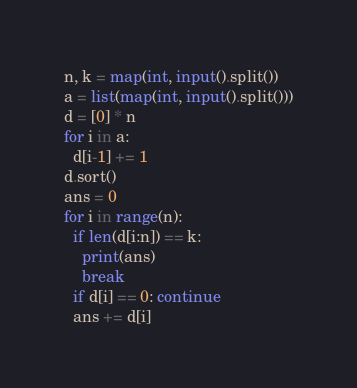<code> <loc_0><loc_0><loc_500><loc_500><_Python_>n, k = map(int, input().split())
a = list(map(int, input().split()))
d = [0] * n
for i in a:
  d[i-1] += 1
d.sort()
ans = 0
for i in range(n):
  if len(d[i:n]) == k:
    print(ans)
    break
  if d[i] == 0: continue
  ans += d[i]</code> 